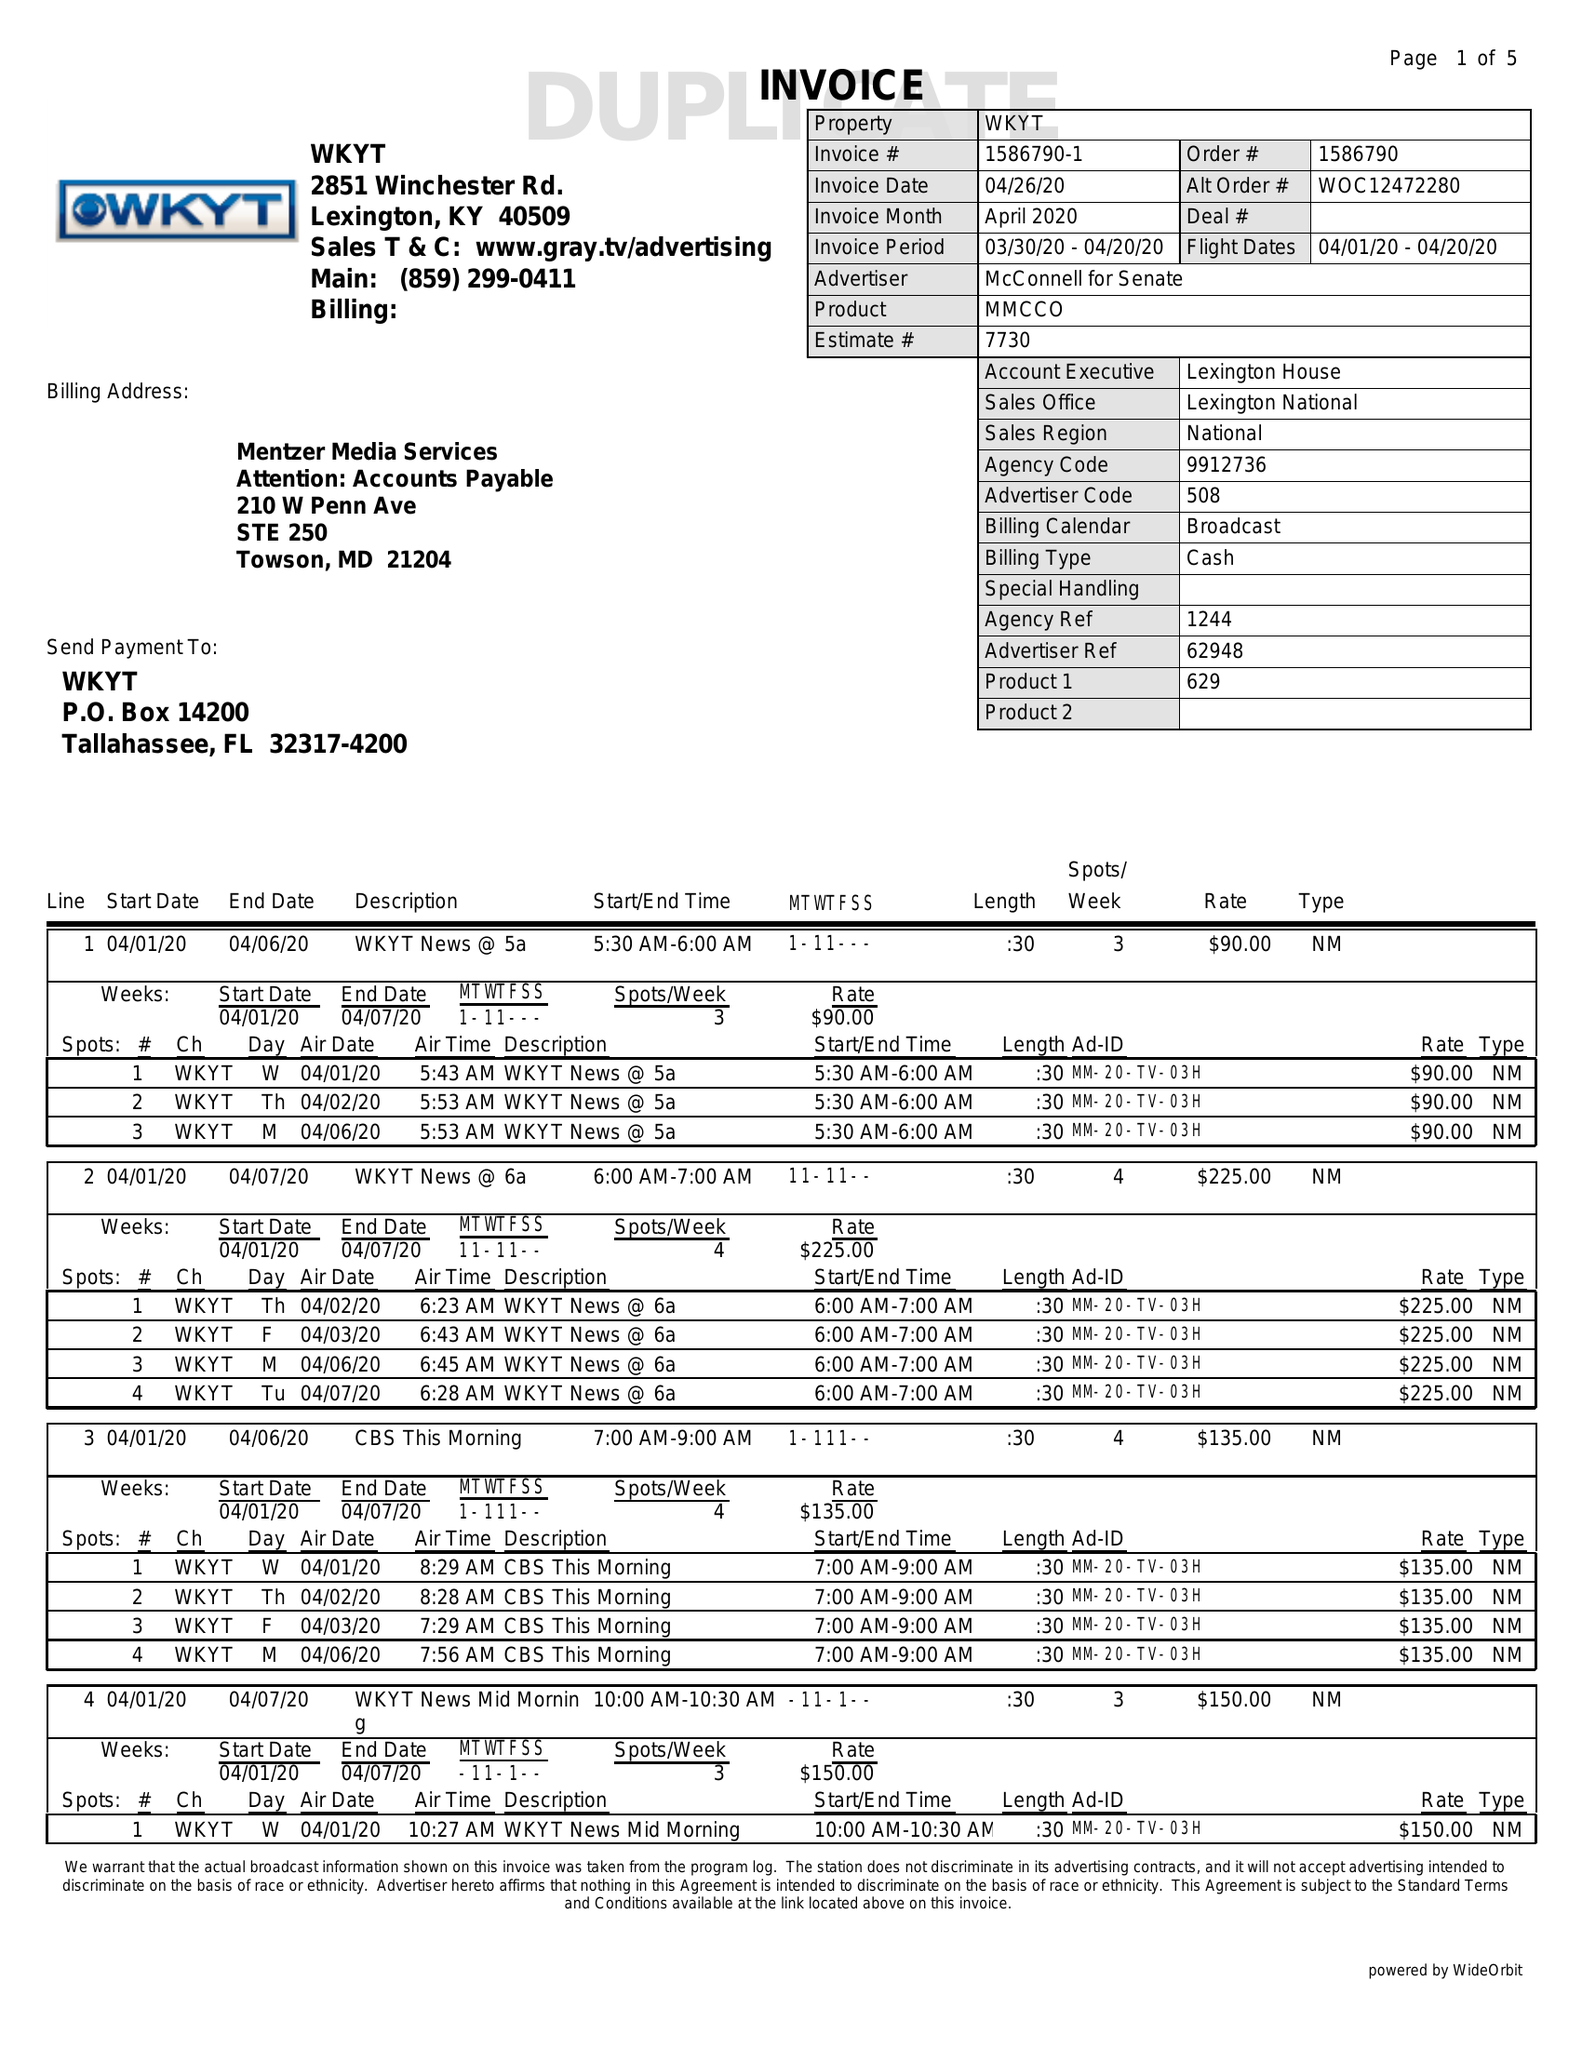What is the value for the gross_amount?
Answer the question using a single word or phrase. 16280.00 